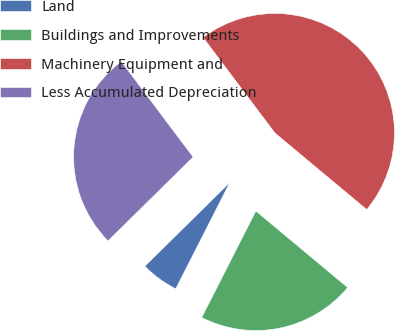Convert chart to OTSL. <chart><loc_0><loc_0><loc_500><loc_500><pie_chart><fcel>Land<fcel>Buildings and Improvements<fcel>Machinery Equipment and<fcel>Less Accumulated Depreciation<nl><fcel>5.12%<fcel>21.43%<fcel>46.32%<fcel>27.13%<nl></chart> 